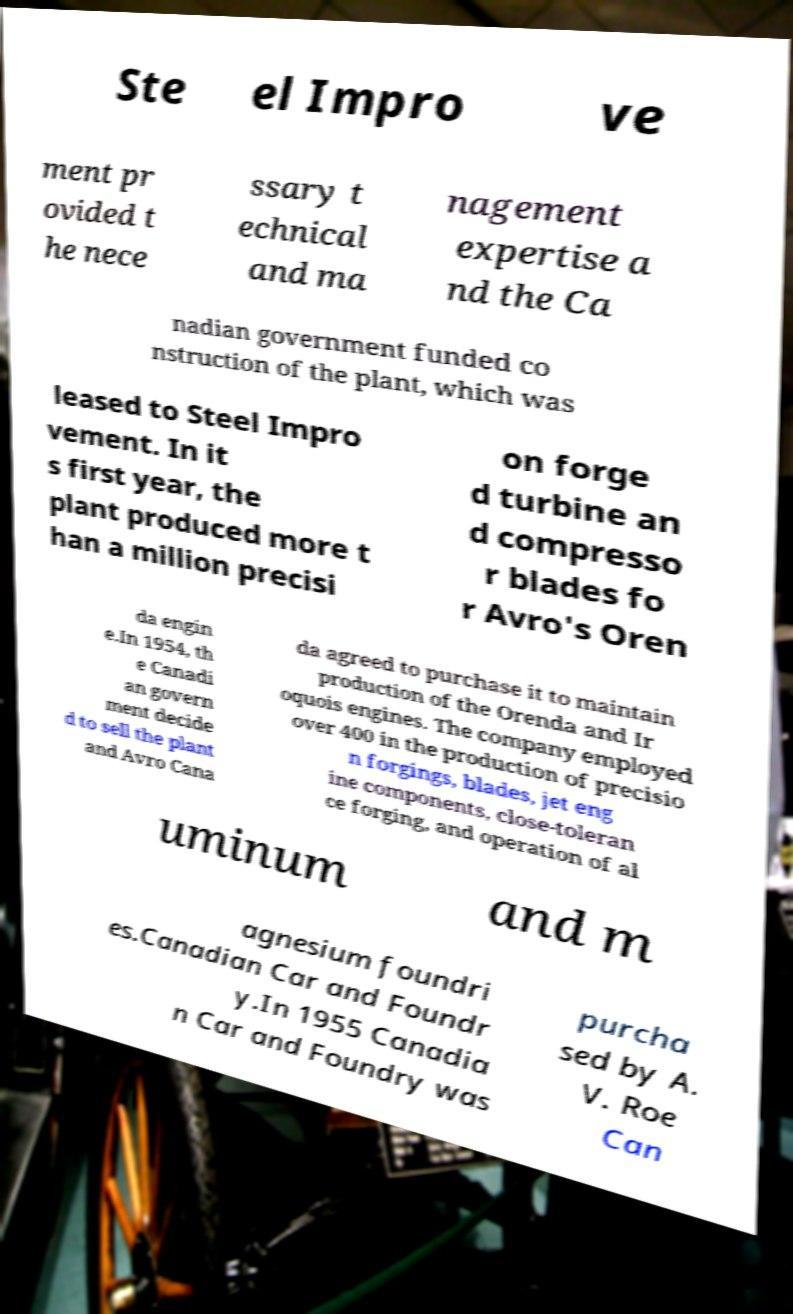For documentation purposes, I need the text within this image transcribed. Could you provide that? Ste el Impro ve ment pr ovided t he nece ssary t echnical and ma nagement expertise a nd the Ca nadian government funded co nstruction of the plant, which was leased to Steel Impro vement. In it s first year, the plant produced more t han a million precisi on forge d turbine an d compresso r blades fo r Avro's Oren da engin e.In 1954, th e Canadi an govern ment decide d to sell the plant and Avro Cana da agreed to purchase it to maintain production of the Orenda and Ir oquois engines. The company employed over 400 in the production of precisio n forgings, blades, jet eng ine components, close-toleran ce forging, and operation of al uminum and m agnesium foundri es.Canadian Car and Foundr y.In 1955 Canadia n Car and Foundry was purcha sed by A. V. Roe Can 